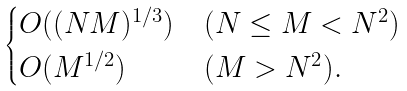Convert formula to latex. <formula><loc_0><loc_0><loc_500><loc_500>\begin{cases} O ( ( N M ) ^ { 1 / 3 } ) & ( N \leq M < N ^ { 2 } ) \\ O ( M ^ { 1 / 2 } ) & ( M > N ^ { 2 } ) . \\ \end{cases}</formula> 